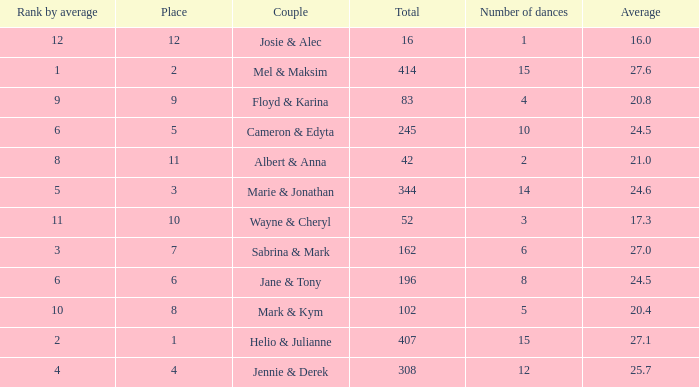What is the average when the rank by average is more than 12? None. 